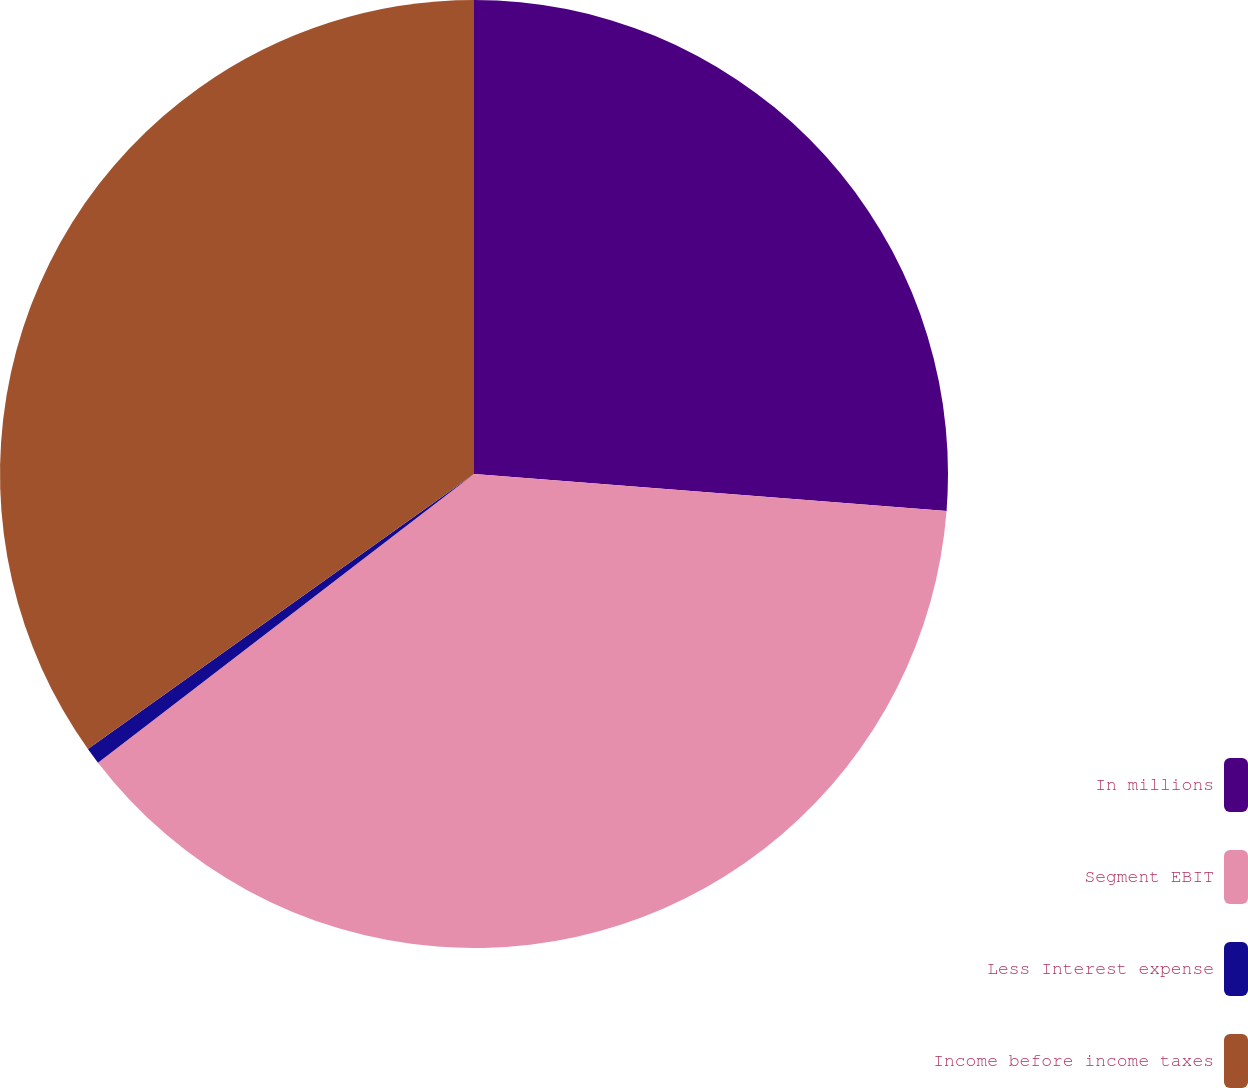<chart> <loc_0><loc_0><loc_500><loc_500><pie_chart><fcel>In millions<fcel>Segment EBIT<fcel>Less Interest expense<fcel>Income before income taxes<nl><fcel>26.24%<fcel>38.34%<fcel>0.57%<fcel>34.85%<nl></chart> 